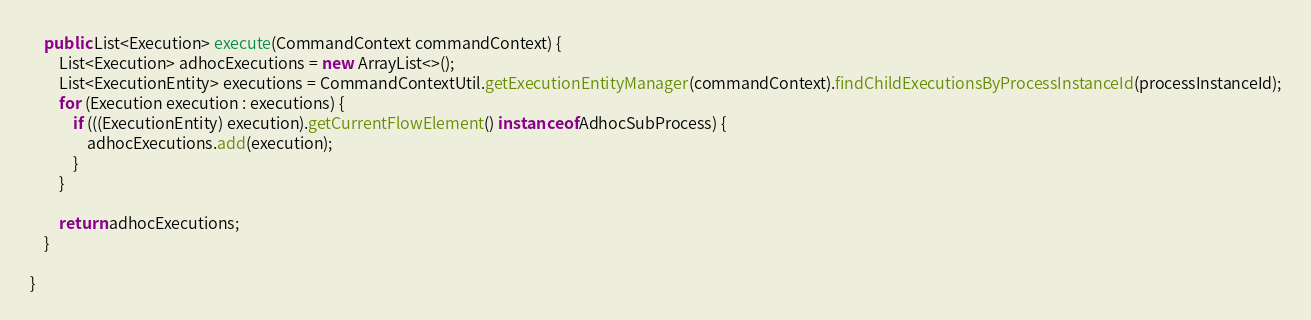<code> <loc_0><loc_0><loc_500><loc_500><_Java_>    public List<Execution> execute(CommandContext commandContext) {
        List<Execution> adhocExecutions = new ArrayList<>();
        List<ExecutionEntity> executions = CommandContextUtil.getExecutionEntityManager(commandContext).findChildExecutionsByProcessInstanceId(processInstanceId);
        for (Execution execution : executions) {
            if (((ExecutionEntity) execution).getCurrentFlowElement() instanceof AdhocSubProcess) {
                adhocExecutions.add(execution);
            }
        }

        return adhocExecutions;
    }

}
</code> 